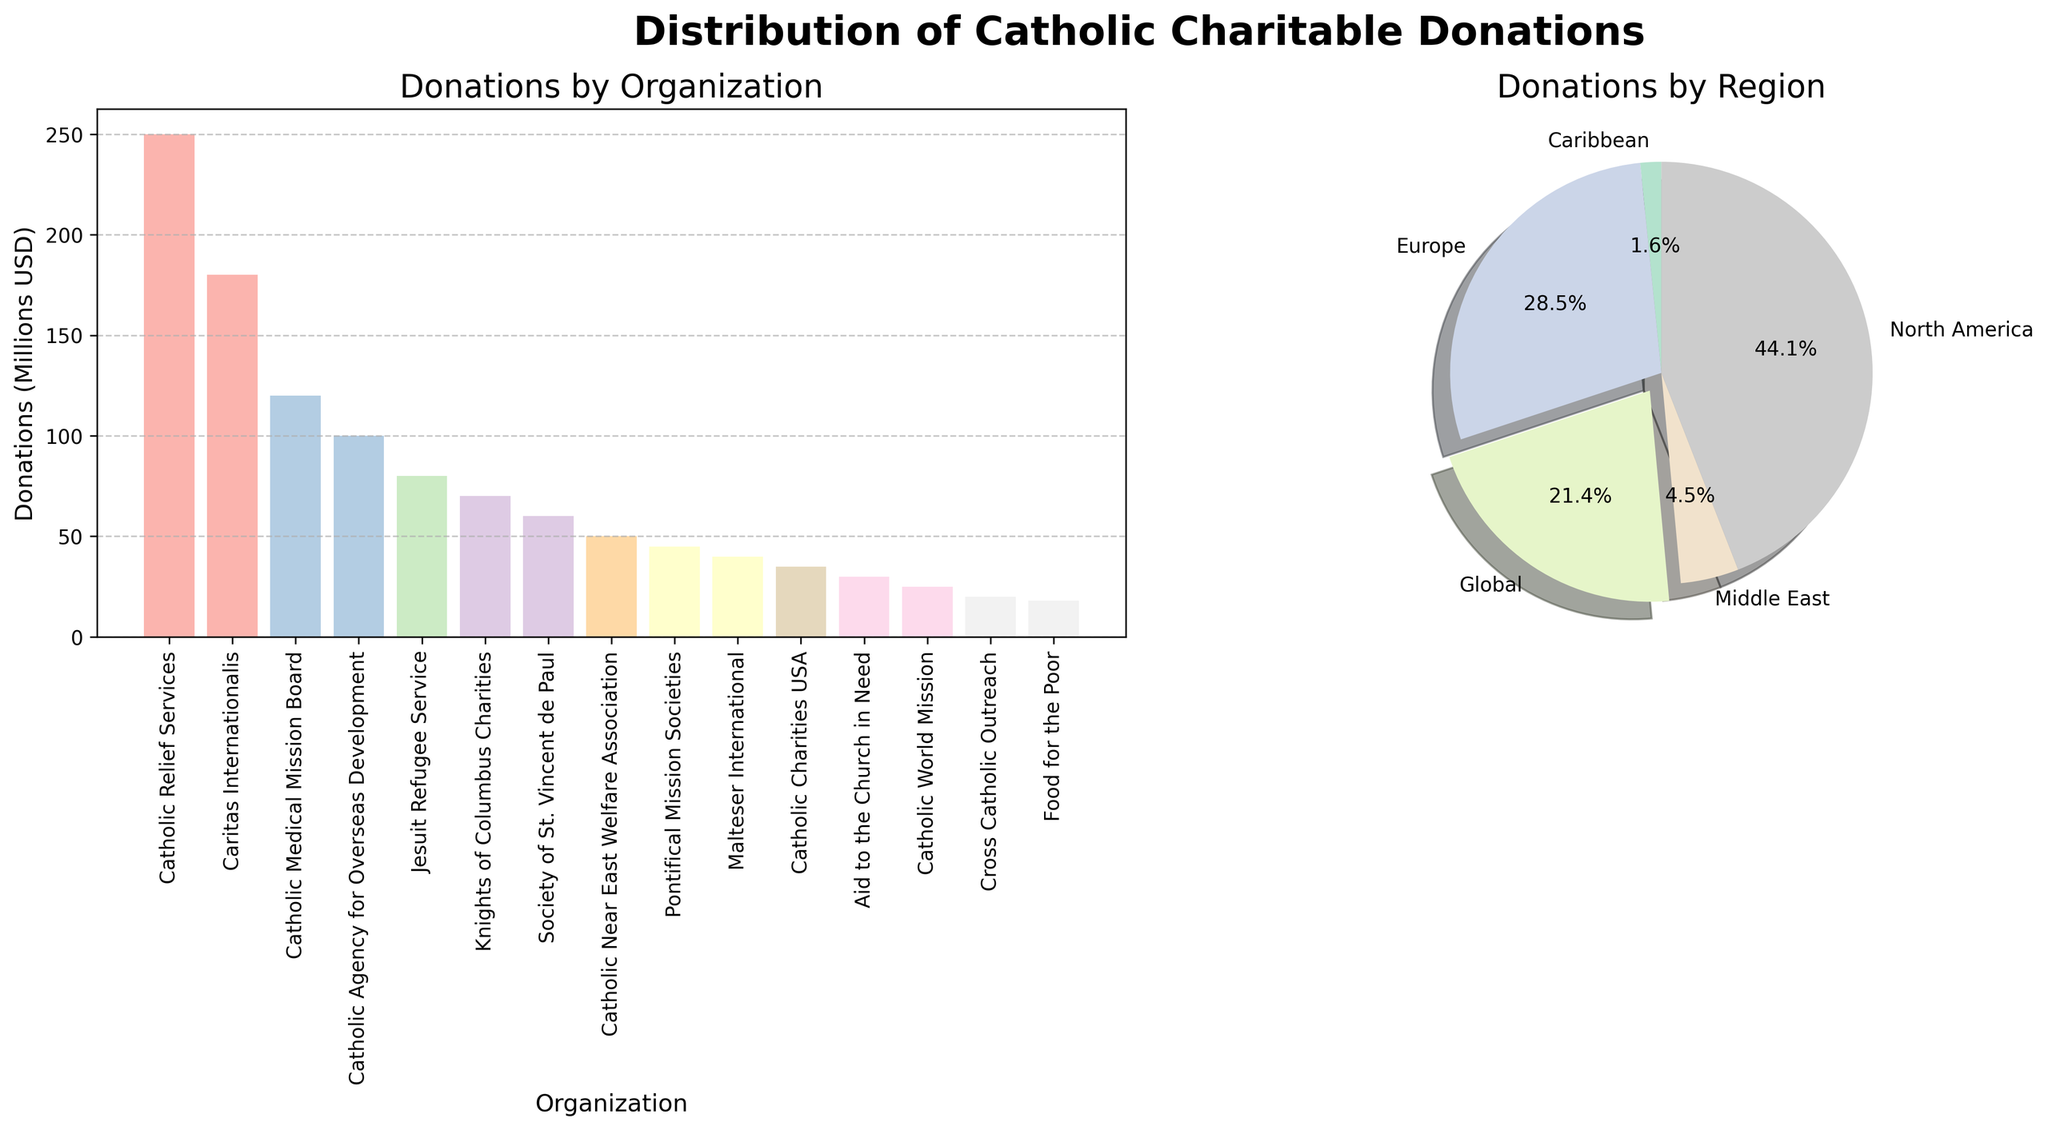What's the title of the bar plot? Look at the title above the bar plot on the left side of the figure.
Answer: Donations by Organization Which organization received the highest amount of donations? Based on the height of the bars in the bar plot, the organization with the tallest bar is Catholic Relief Services.
Answer: Catholic Relief Services What percentage of total donations go to Global regions? In the pie chart, find the "Global" segment and check its percentage label. The label shows 34.6%.
Answer: 34.6% How many organizations have donation amounts listed on the bar plot? Count the number of bars on the bar plot.
Answer: 15 Compare the sum of donations between North America and Europe. Which region has a higher total donation? Add the donations for each organization listed under North America and Europe separately. North America: 250 + 120 + 70 + 35 + 20 = 495. Europe: 180 + 100 + 40 = 320. North America has a higher total donation.
Answer: North America What is the combined donation amount for organizations listed under the Global region? Identify organizations labeled as "Global" in the table and sum their donations: 80 + 60 + 45 + 30 + 25 = 240.
Answer: 240 What's the smallest donation amount listed in the bar plot? Identify the shortest bar in the bar plot, which corresponds to the organization "Food for the Poor" with 18 million USD.
Answer: 18 Which region has the lowest total donations according to the pie chart? In the pie chart, find the segment with the smallest percentage. The Caribbean region has the smallest percentage.
Answer: Caribbean How many regions are represented in the pie chart? Count the number of different labels in the pie chart's legend.
Answer: 5 Compare the total donations for the Caribbean region to the Canadian Relief Services. Which is higher? Caribbean's total donation is 18 million USD (Food for the Poor). Catholic Relief Services received 250 million USD, which is higher.
Answer: Catholic Relief Services 